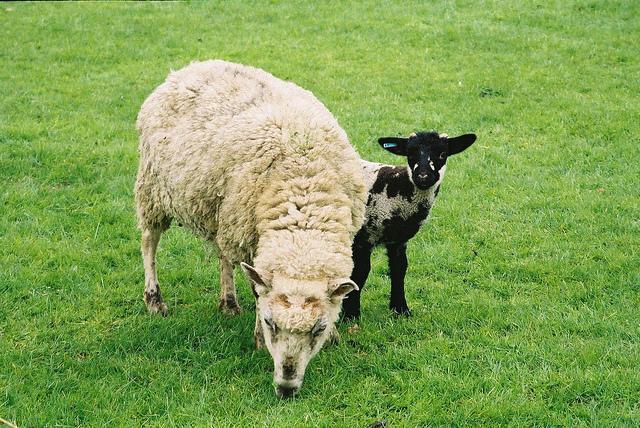How many sheep legs are visible in the photo?
Give a very brief answer. 4. How many sheep are in the image?
Give a very brief answer. 2. How many sheep are in the picture?
Give a very brief answer. 2. How many dogs are in the photo?
Give a very brief answer. 0. 